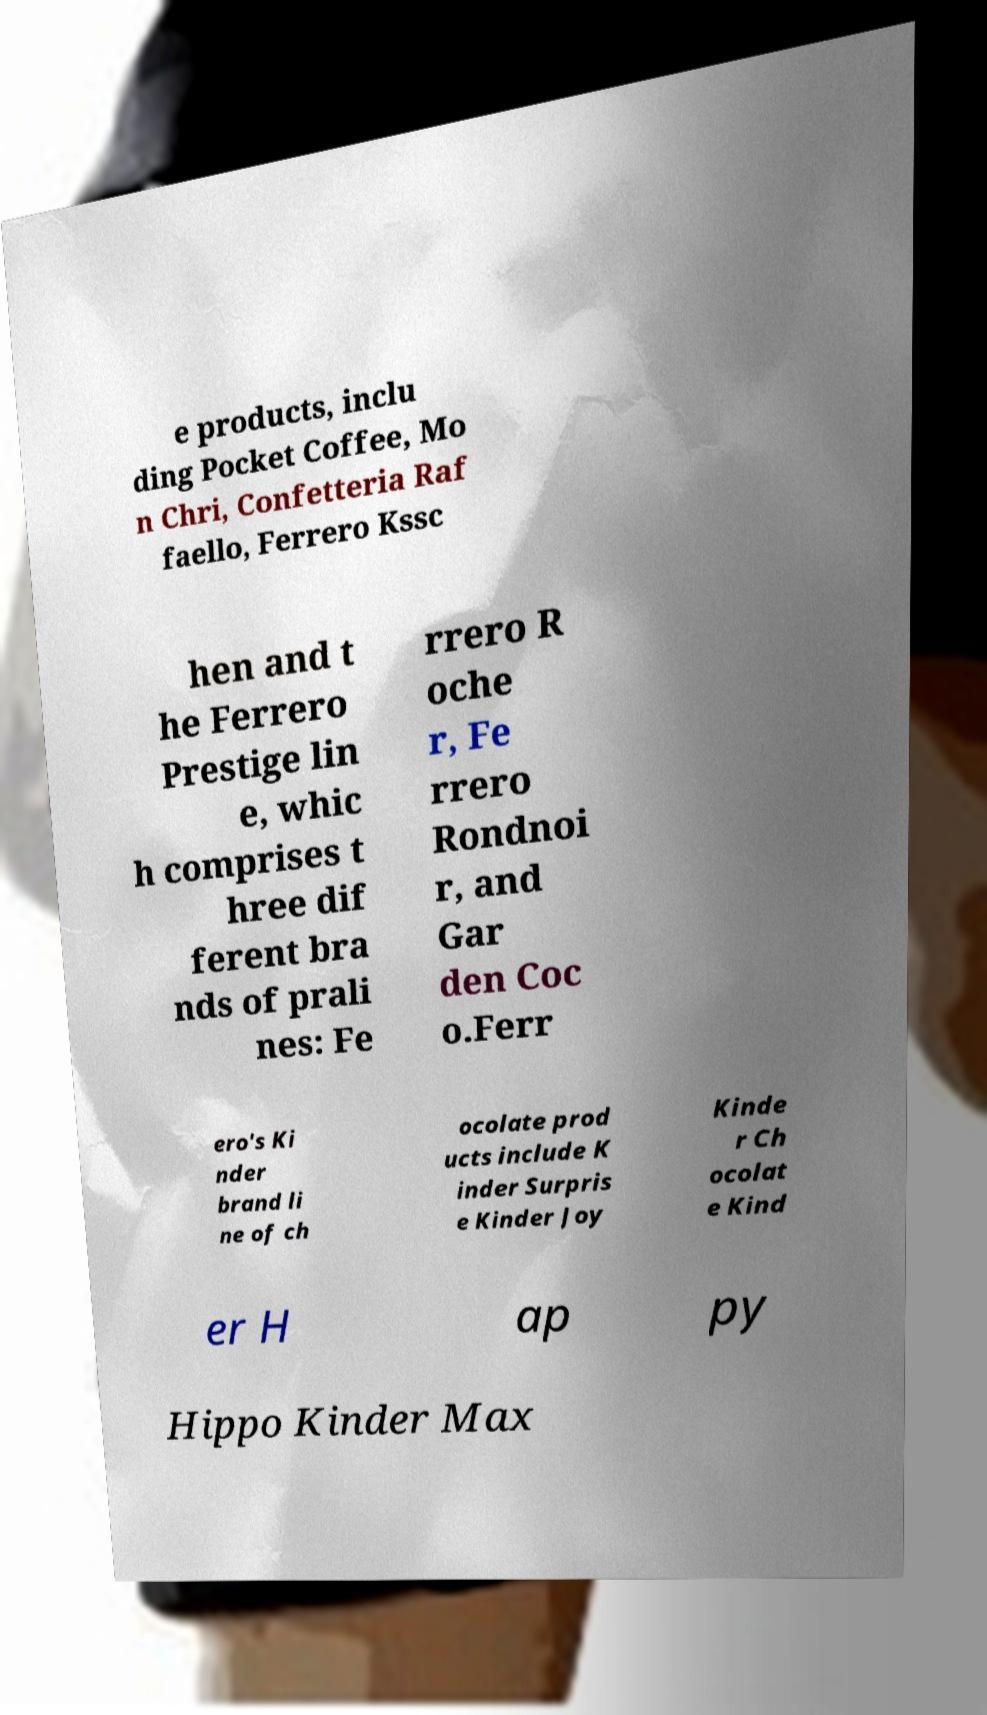For documentation purposes, I need the text within this image transcribed. Could you provide that? e products, inclu ding Pocket Coffee, Mo n Chri, Confetteria Raf faello, Ferrero Kssc hen and t he Ferrero Prestige lin e, whic h comprises t hree dif ferent bra nds of prali nes: Fe rrero R oche r, Fe rrero Rondnoi r, and Gar den Coc o.Ferr ero's Ki nder brand li ne of ch ocolate prod ucts include K inder Surpris e Kinder Joy Kinde r Ch ocolat e Kind er H ap py Hippo Kinder Max 